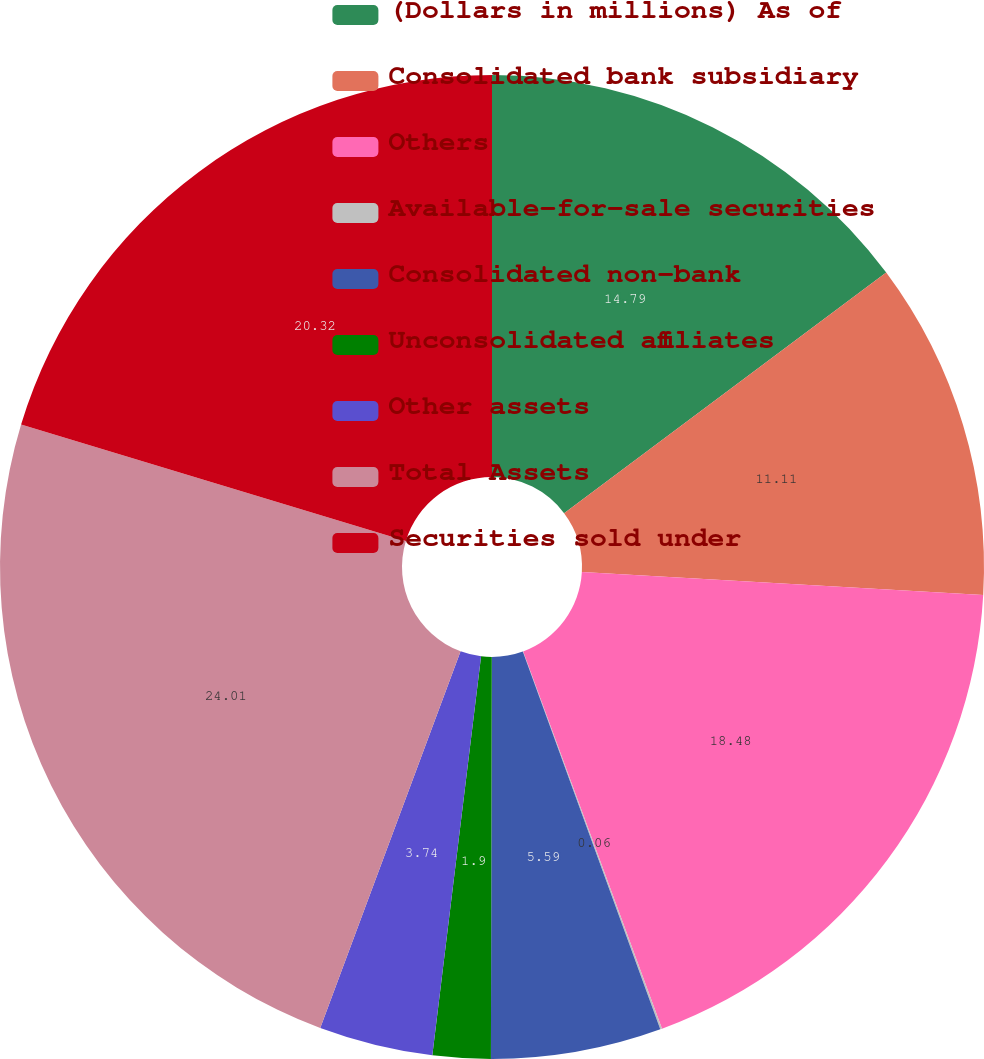Convert chart. <chart><loc_0><loc_0><loc_500><loc_500><pie_chart><fcel>(Dollars in millions) As of<fcel>Consolidated bank subsidiary<fcel>Others<fcel>Available-for-sale securities<fcel>Consolidated non-bank<fcel>Unconsolidated affiliates<fcel>Other assets<fcel>Total Assets<fcel>Securities sold under<nl><fcel>14.79%<fcel>11.11%<fcel>18.48%<fcel>0.06%<fcel>5.59%<fcel>1.9%<fcel>3.74%<fcel>24.0%<fcel>20.32%<nl></chart> 